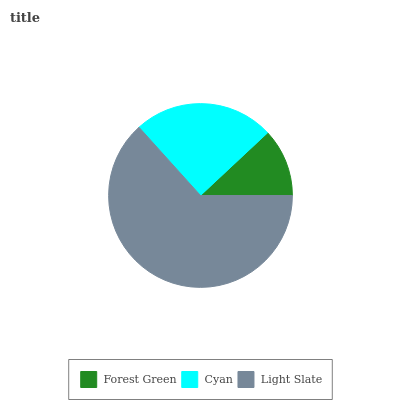Is Forest Green the minimum?
Answer yes or no. Yes. Is Light Slate the maximum?
Answer yes or no. Yes. Is Cyan the minimum?
Answer yes or no. No. Is Cyan the maximum?
Answer yes or no. No. Is Cyan greater than Forest Green?
Answer yes or no. Yes. Is Forest Green less than Cyan?
Answer yes or no. Yes. Is Forest Green greater than Cyan?
Answer yes or no. No. Is Cyan less than Forest Green?
Answer yes or no. No. Is Cyan the high median?
Answer yes or no. Yes. Is Cyan the low median?
Answer yes or no. Yes. Is Forest Green the high median?
Answer yes or no. No. Is Light Slate the low median?
Answer yes or no. No. 